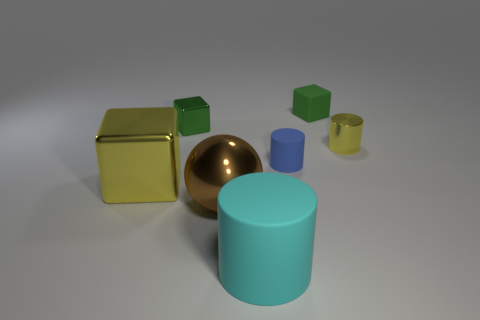Do the cube in front of the yellow cylinder and the green cube that is to the right of the small green shiny cube have the same size? The cube in front of the yellow cylinder appears to be larger than the green cube that is situated to the right of the small shiny green cube. 